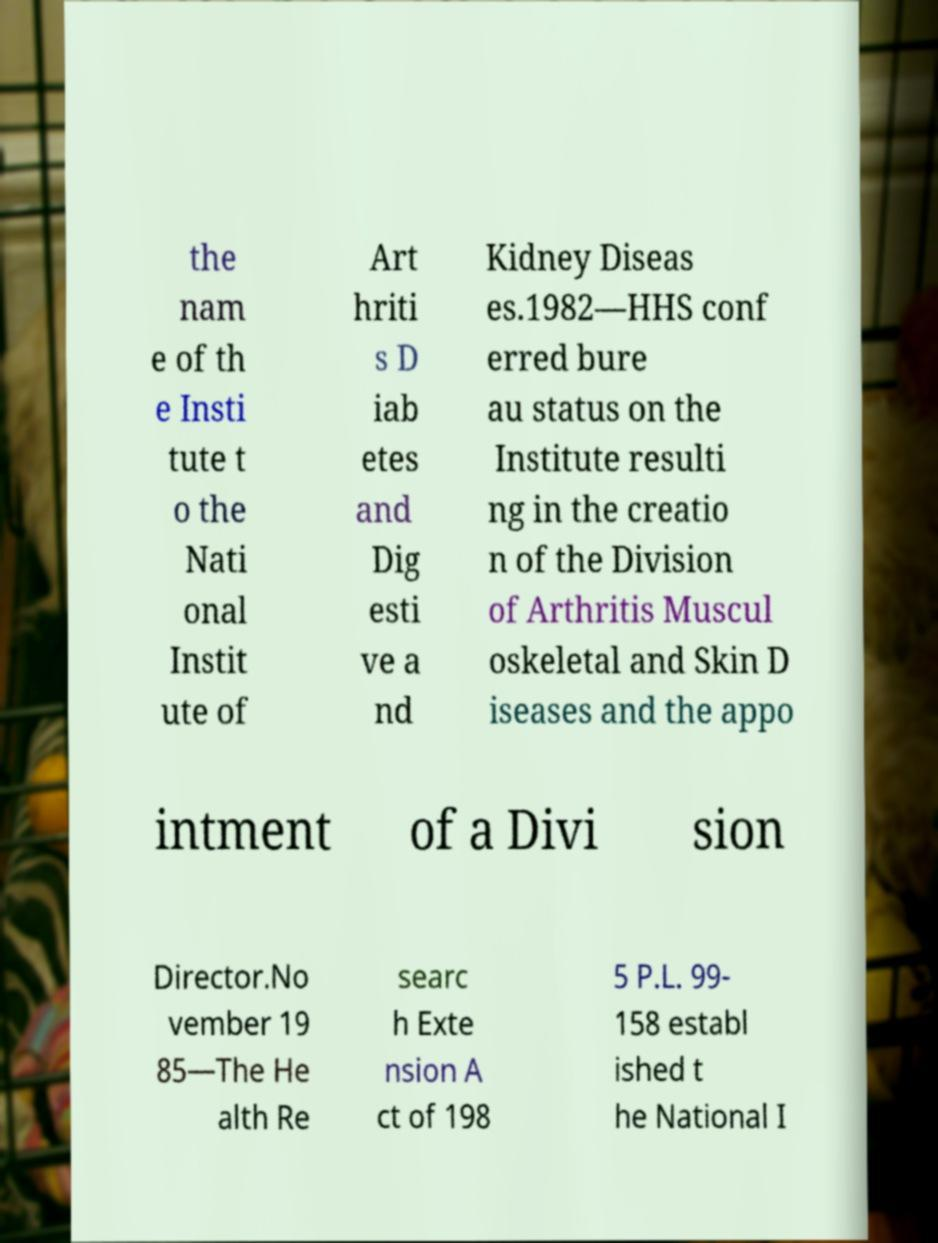Please identify and transcribe the text found in this image. the nam e of th e Insti tute t o the Nati onal Instit ute of Art hriti s D iab etes and Dig esti ve a nd Kidney Diseas es.1982—HHS conf erred bure au status on the Institute resulti ng in the creatio n of the Division of Arthritis Muscul oskeletal and Skin D iseases and the appo intment of a Divi sion Director.No vember 19 85—The He alth Re searc h Exte nsion A ct of 198 5 P.L. 99- 158 establ ished t he National I 